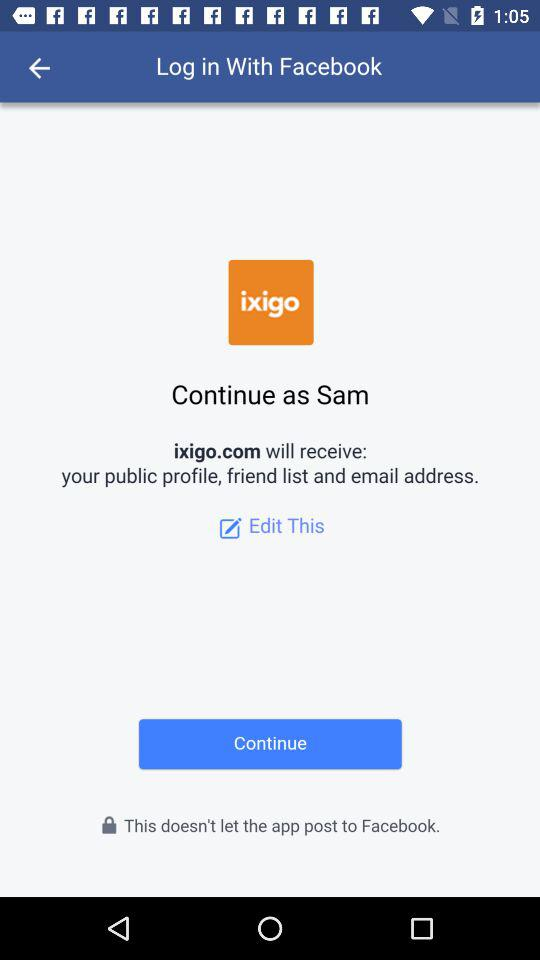Which information will "ixigo.com" receive? "ixigo.com" will receive your public profile, friend list and email address. 